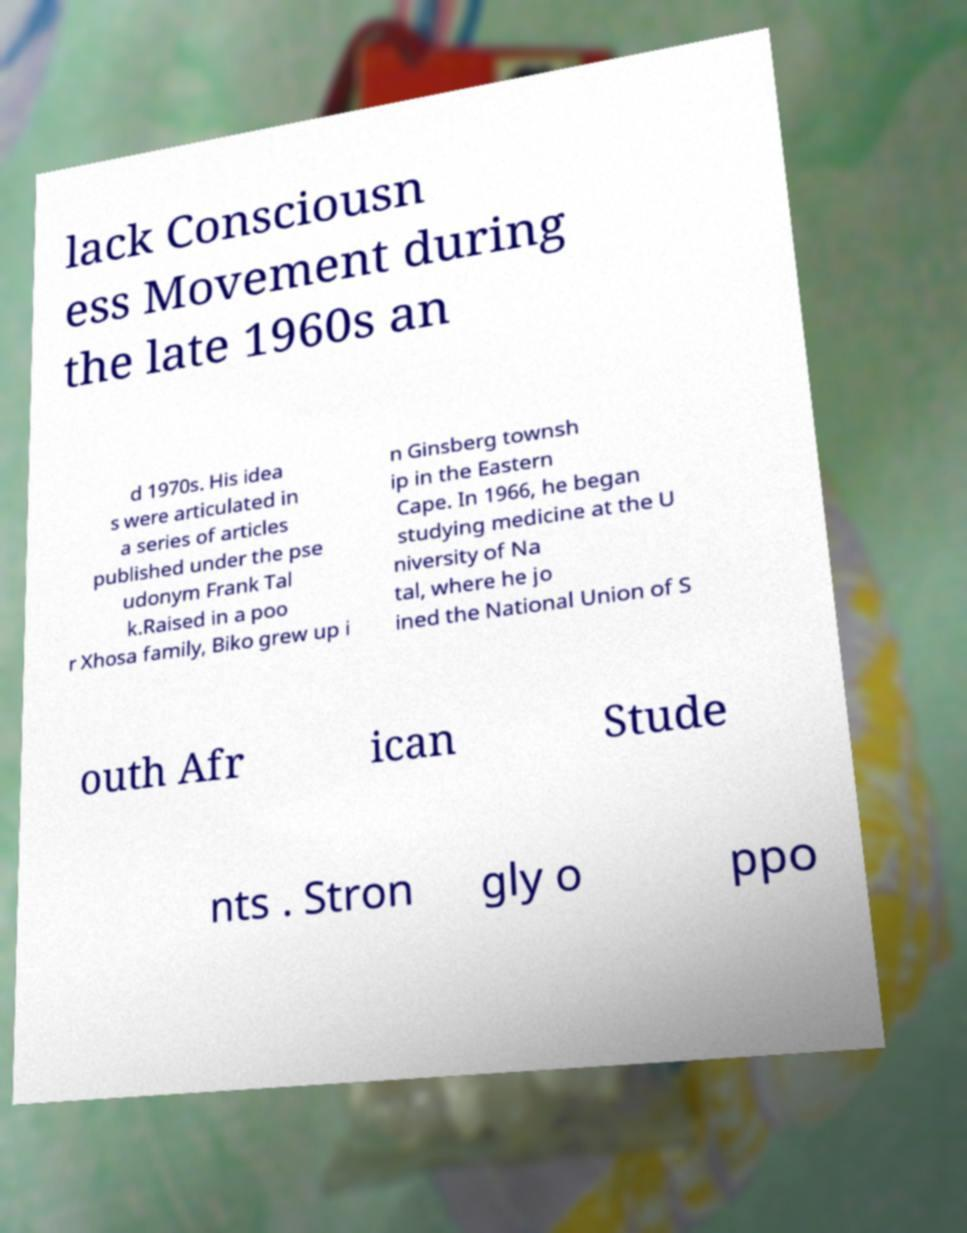Can you read and provide the text displayed in the image?This photo seems to have some interesting text. Can you extract and type it out for me? lack Consciousn ess Movement during the late 1960s an d 1970s. His idea s were articulated in a series of articles published under the pse udonym Frank Tal k.Raised in a poo r Xhosa family, Biko grew up i n Ginsberg townsh ip in the Eastern Cape. In 1966, he began studying medicine at the U niversity of Na tal, where he jo ined the National Union of S outh Afr ican Stude nts . Stron gly o ppo 